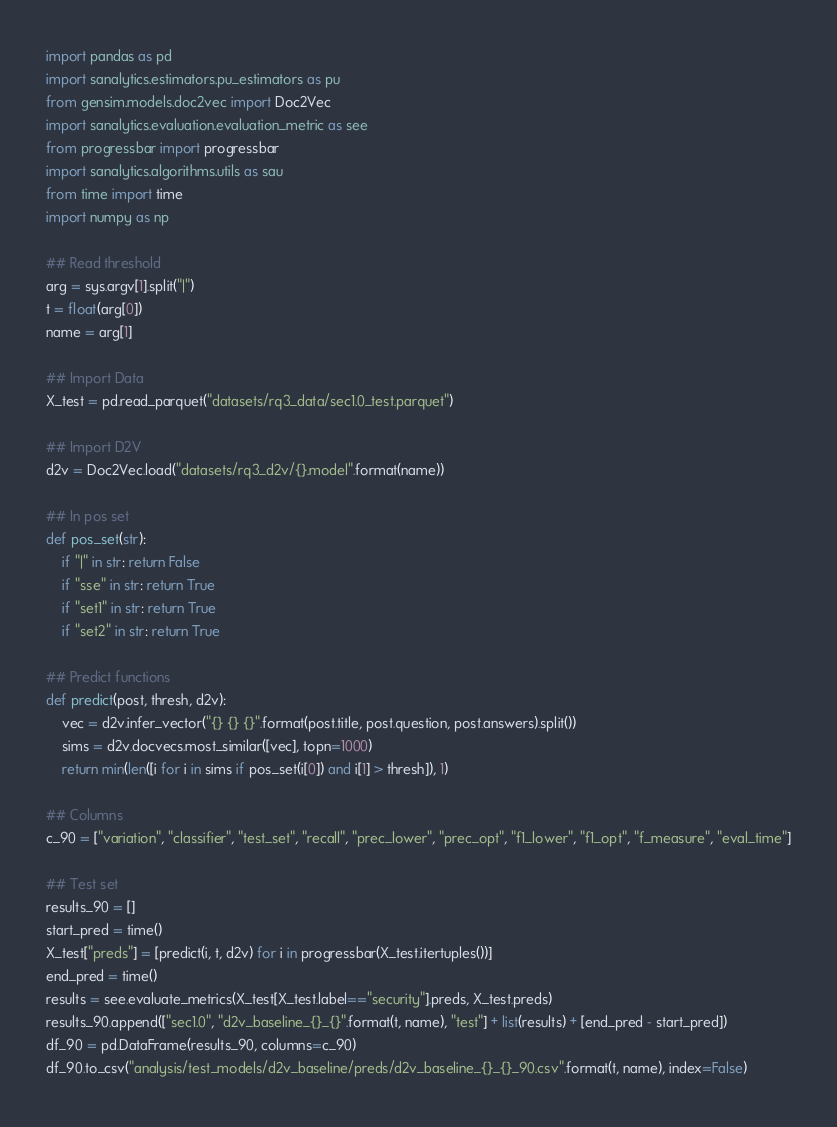<code> <loc_0><loc_0><loc_500><loc_500><_Python_>import pandas as pd
import sanalytics.estimators.pu_estimators as pu
from gensim.models.doc2vec import Doc2Vec
import sanalytics.evaluation.evaluation_metric as see
from progressbar import progressbar
import sanalytics.algorithms.utils as sau
from time import time
import numpy as np

## Read threshold
arg = sys.argv[1].split("|")
t = float(arg[0])
name = arg[1]

## Import Data
X_test = pd.read_parquet("datasets/rq3_data/sec1.0_test.parquet")

## Import D2V
d2v = Doc2Vec.load("datasets/rq3_d2v/{}.model".format(name))

## In pos set
def pos_set(str):
    if "|" in str: return False
    if "sse" in str: return True
    if "set1" in str: return True
    if "set2" in str: return True

## Predict functions
def predict(post, thresh, d2v):
    vec = d2v.infer_vector("{} {} {}".format(post.title, post.question, post.answers).split())
    sims = d2v.docvecs.most_similar([vec], topn=1000)
    return min(len([i for i in sims if pos_set(i[0]) and i[1] > thresh]), 1)

## Columns
c_90 = ["variation", "classifier", "test_set", "recall", "prec_lower", "prec_opt", "f1_lower", "f1_opt", "f_measure", "eval_time"]

## Test set
results_90 = []
start_pred = time()
X_test["preds"] = [predict(i, t, d2v) for i in progressbar(X_test.itertuples())]
end_pred = time()
results = see.evaluate_metrics(X_test[X_test.label=="security"].preds, X_test.preds)
results_90.append(["sec1.0", "d2v_baseline_{}_{}".format(t, name), "test"] + list(results) + [end_pred - start_pred])
df_90 = pd.DataFrame(results_90, columns=c_90)
df_90.to_csv("analysis/test_models/d2v_baseline/preds/d2v_baseline_{}_{}_90.csv".format(t, name), index=False)
</code> 